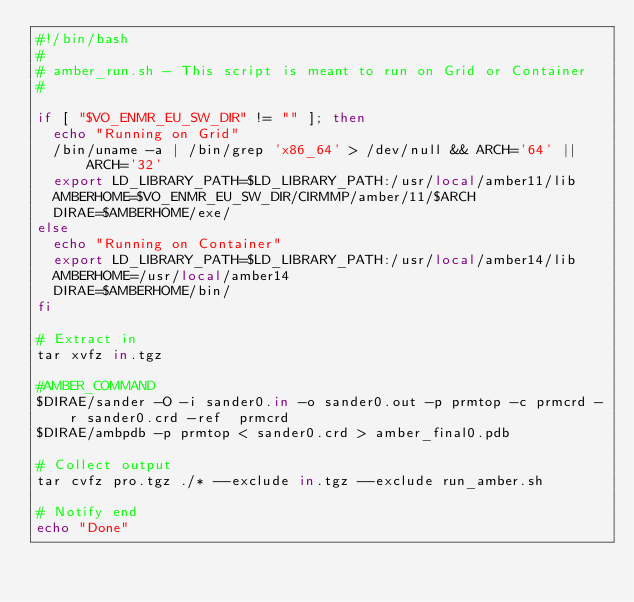Convert code to text. <code><loc_0><loc_0><loc_500><loc_500><_Bash_>#!/bin/bash
#
# amber_run.sh - This script is meant to run on Grid or Container
#

if [ "$VO_ENMR_EU_SW_DIR" != "" ]; then
  echo "Running on Grid"
  /bin/uname -a | /bin/grep 'x86_64' > /dev/null && ARCH='64' || ARCH='32'
  export LD_LIBRARY_PATH=$LD_LIBRARY_PATH:/usr/local/amber11/lib
  AMBERHOME=$VO_ENMR_EU_SW_DIR/CIRMMP/amber/11/$ARCH
  DIRAE=$AMBERHOME/exe/
else
  echo "Running on Container"
  export LD_LIBRARY_PATH=$LD_LIBRARY_PATH:/usr/local/amber14/lib
  AMBERHOME=/usr/local/amber14
  DIRAE=$AMBERHOME/bin/
fi

# Extract in
tar xvfz in.tgz

#AMBER_COMMAND
$DIRAE/sander -O -i sander0.in -o sander0.out -p prmtop -c prmcrd -r sander0.crd -ref  prmcrd
$DIRAE/ambpdb -p prmtop < sander0.crd > amber_final0.pdb

# Collect output
tar cvfz pro.tgz ./* --exclude in.tgz --exclude run_amber.sh

# Notify end
echo "Done"
</code> 